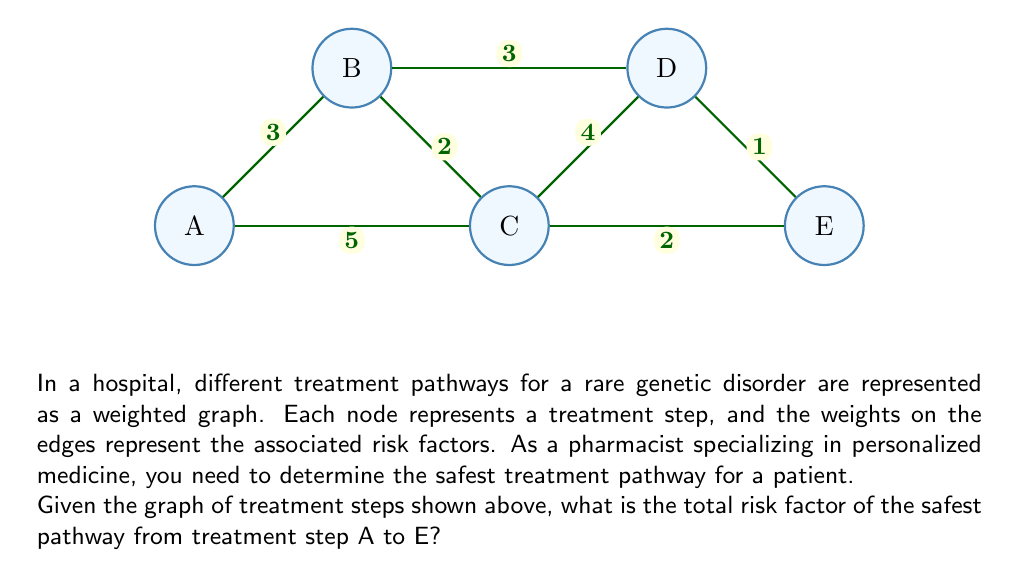Show me your answer to this math problem. To find the safest pathway from A to E, we need to use Dijkstra's algorithm, which is an efficient shortest path algorithm. In this case, we're looking for the path with the lowest total risk factor.

Step 1: Initialize distances
- Set distance to A as 0
- Set distances to all other nodes as infinity

Step 2: Visit node A
- Update distances:
  B: min(∞, 0 + 3) = 3
  C: min(∞, 0 + 5) = 5

Step 3: Visit node B (closest unvisited node)
- Update distances:
  C: min(5, 3 + 2) = 5
  D: min(∞, 3 + 3) = 6

Step 4: Visit node C
- Update distances:
  D: min(6, 5 + 4) = 6
  E: min(∞, 5 + 2) = 7

Step 5: Visit node D
- Update distances:
  E: min(7, 6 + 1) = 7

Step 6: Visit node E
- All nodes visited, algorithm terminates

The safest pathway is A → C → E with a total risk factor of 7.
Answer: 7 